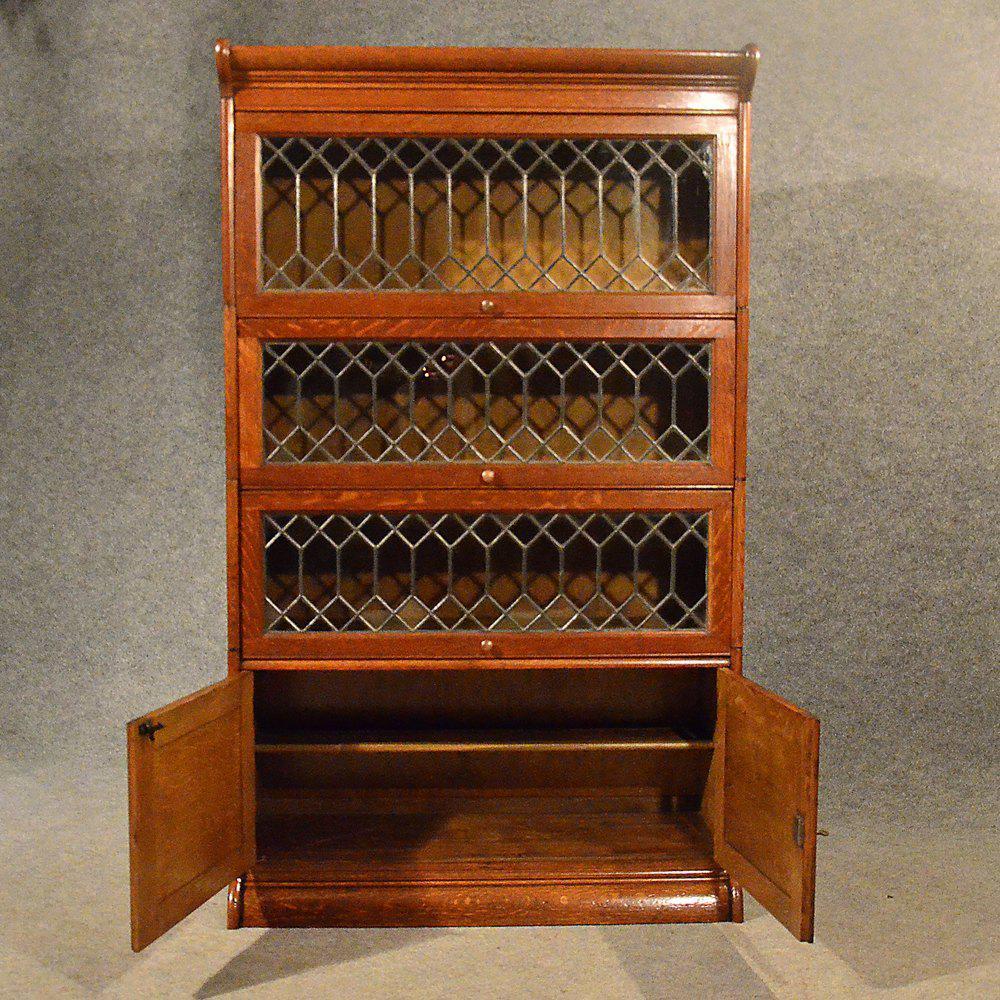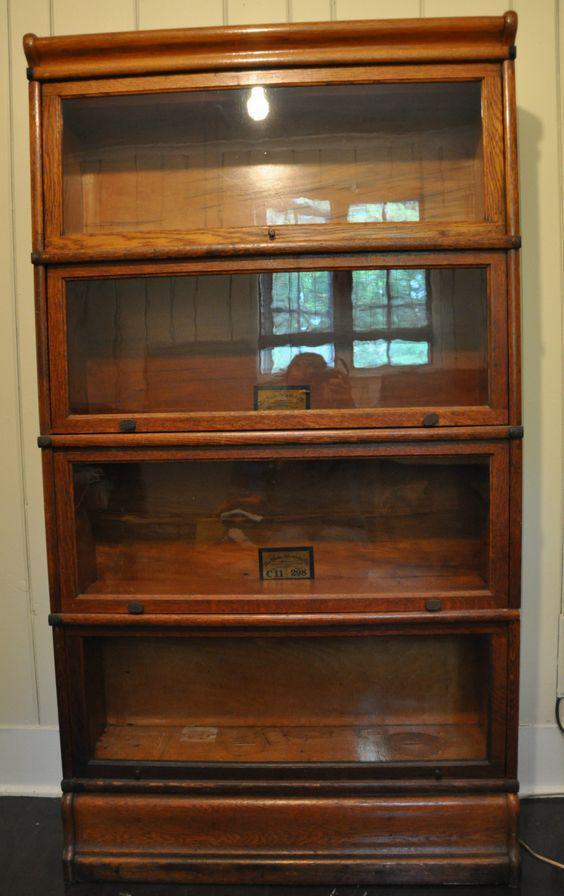The first image is the image on the left, the second image is the image on the right. Assess this claim about the two images: "One of the photos shows a wooden bookcase with at most three shelves.". Correct or not? Answer yes or no. No. The first image is the image on the left, the second image is the image on the right. For the images displayed, is the sentence "there is a book case, outdoors with 3 shelves" factually correct? Answer yes or no. No. 